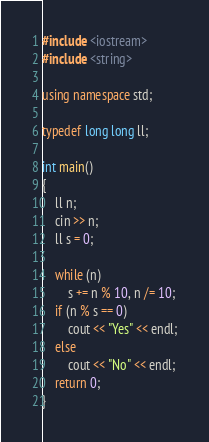<code> <loc_0><loc_0><loc_500><loc_500><_C++_>#include <iostream>
#include <string>

using namespace std;

typedef long long ll;

int main()
{
    ll n;
    cin >> n;
    ll s = 0;

    while (n)
        s += n % 10, n /= 10;
    if (n % s == 0)
        cout << "Yes" << endl;
    else
        cout << "No" << endl;
    return 0;
}</code> 